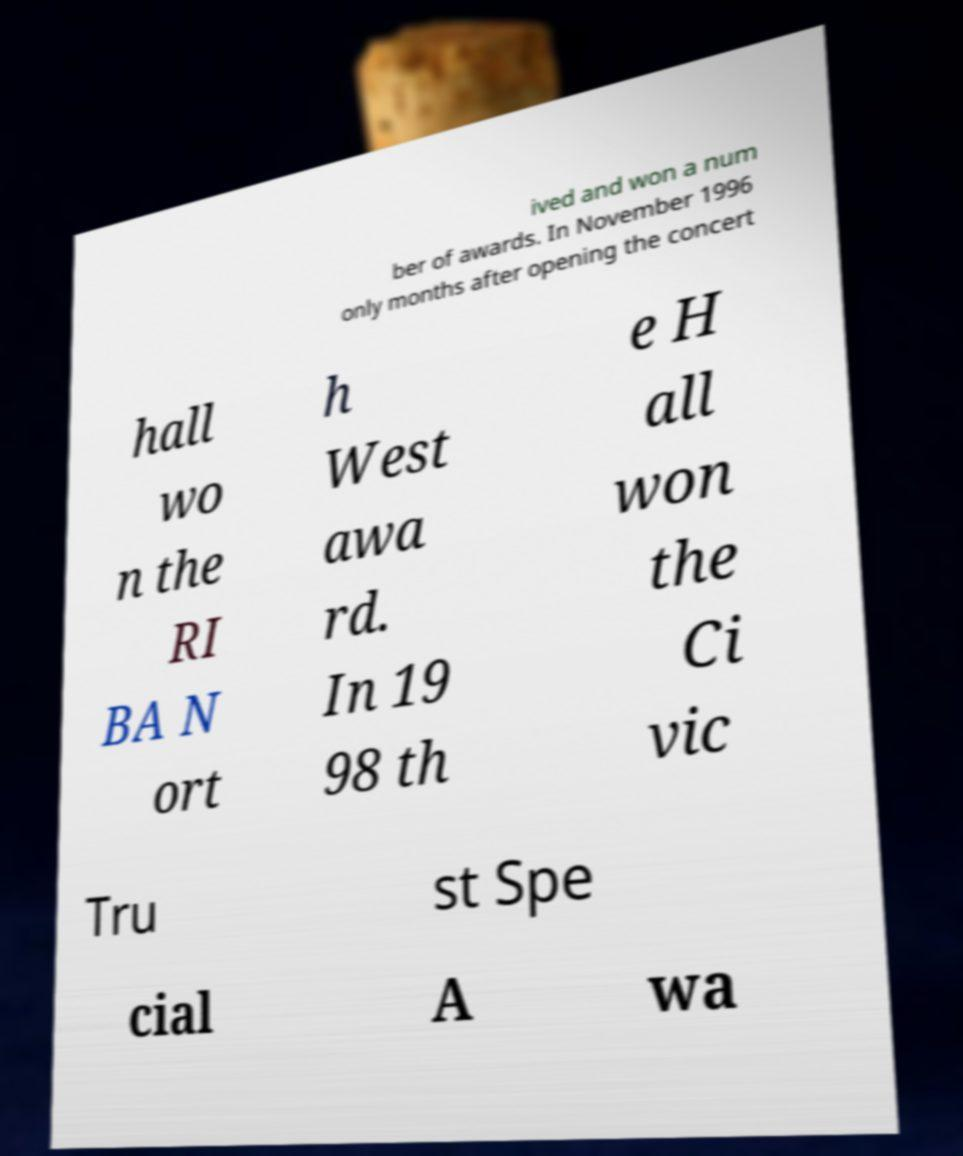There's text embedded in this image that I need extracted. Can you transcribe it verbatim? ived and won a num ber of awards. In November 1996 only months after opening the concert hall wo n the RI BA N ort h West awa rd. In 19 98 th e H all won the Ci vic Tru st Spe cial A wa 